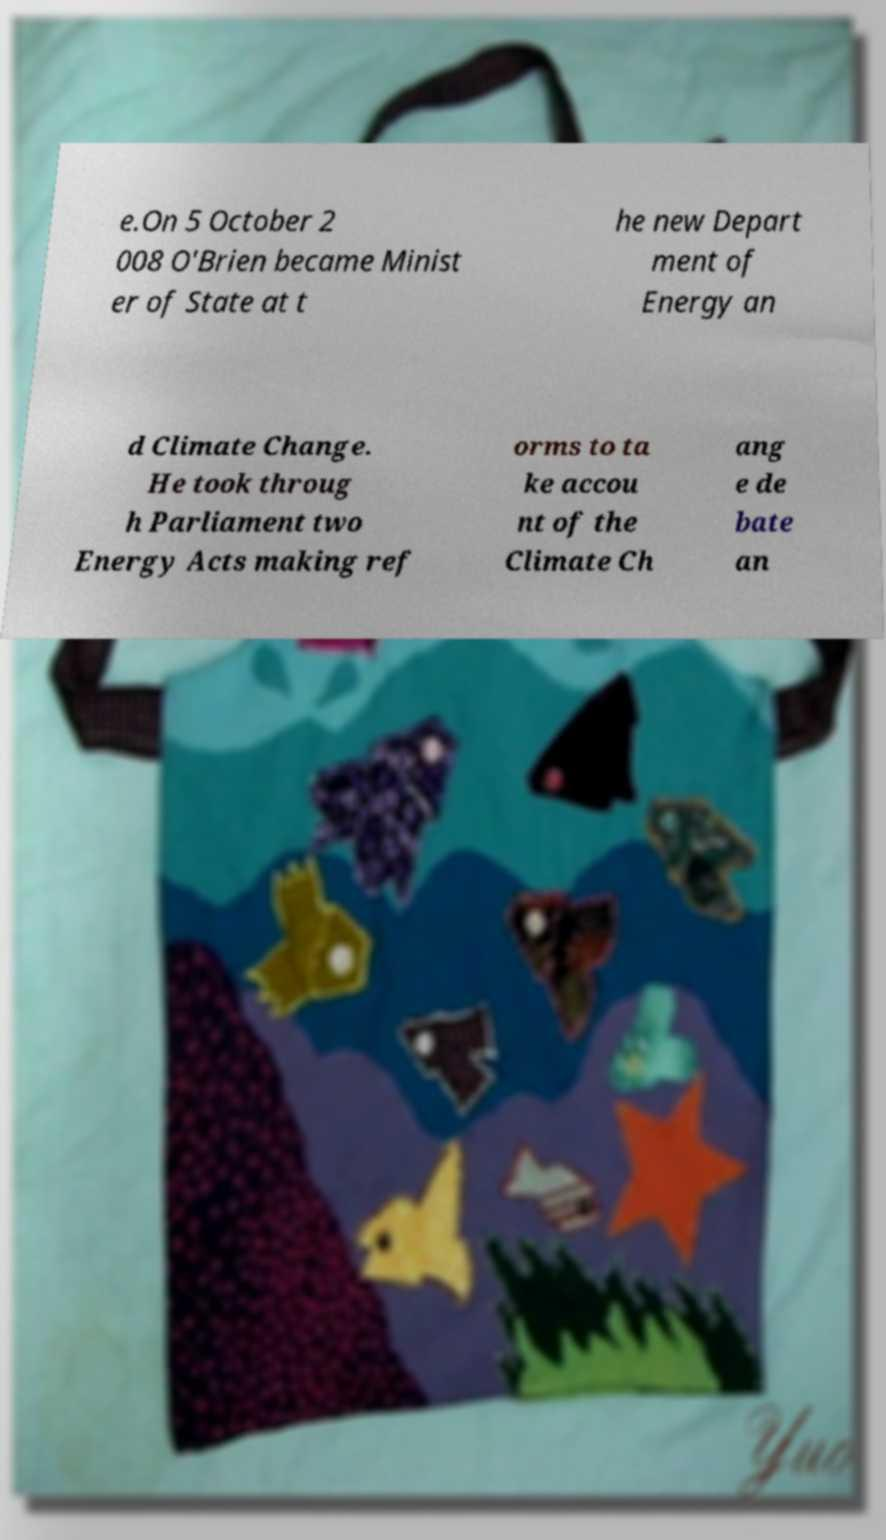Could you assist in decoding the text presented in this image and type it out clearly? e.On 5 October 2 008 O'Brien became Minist er of State at t he new Depart ment of Energy an d Climate Change. He took throug h Parliament two Energy Acts making ref orms to ta ke accou nt of the Climate Ch ang e de bate an 